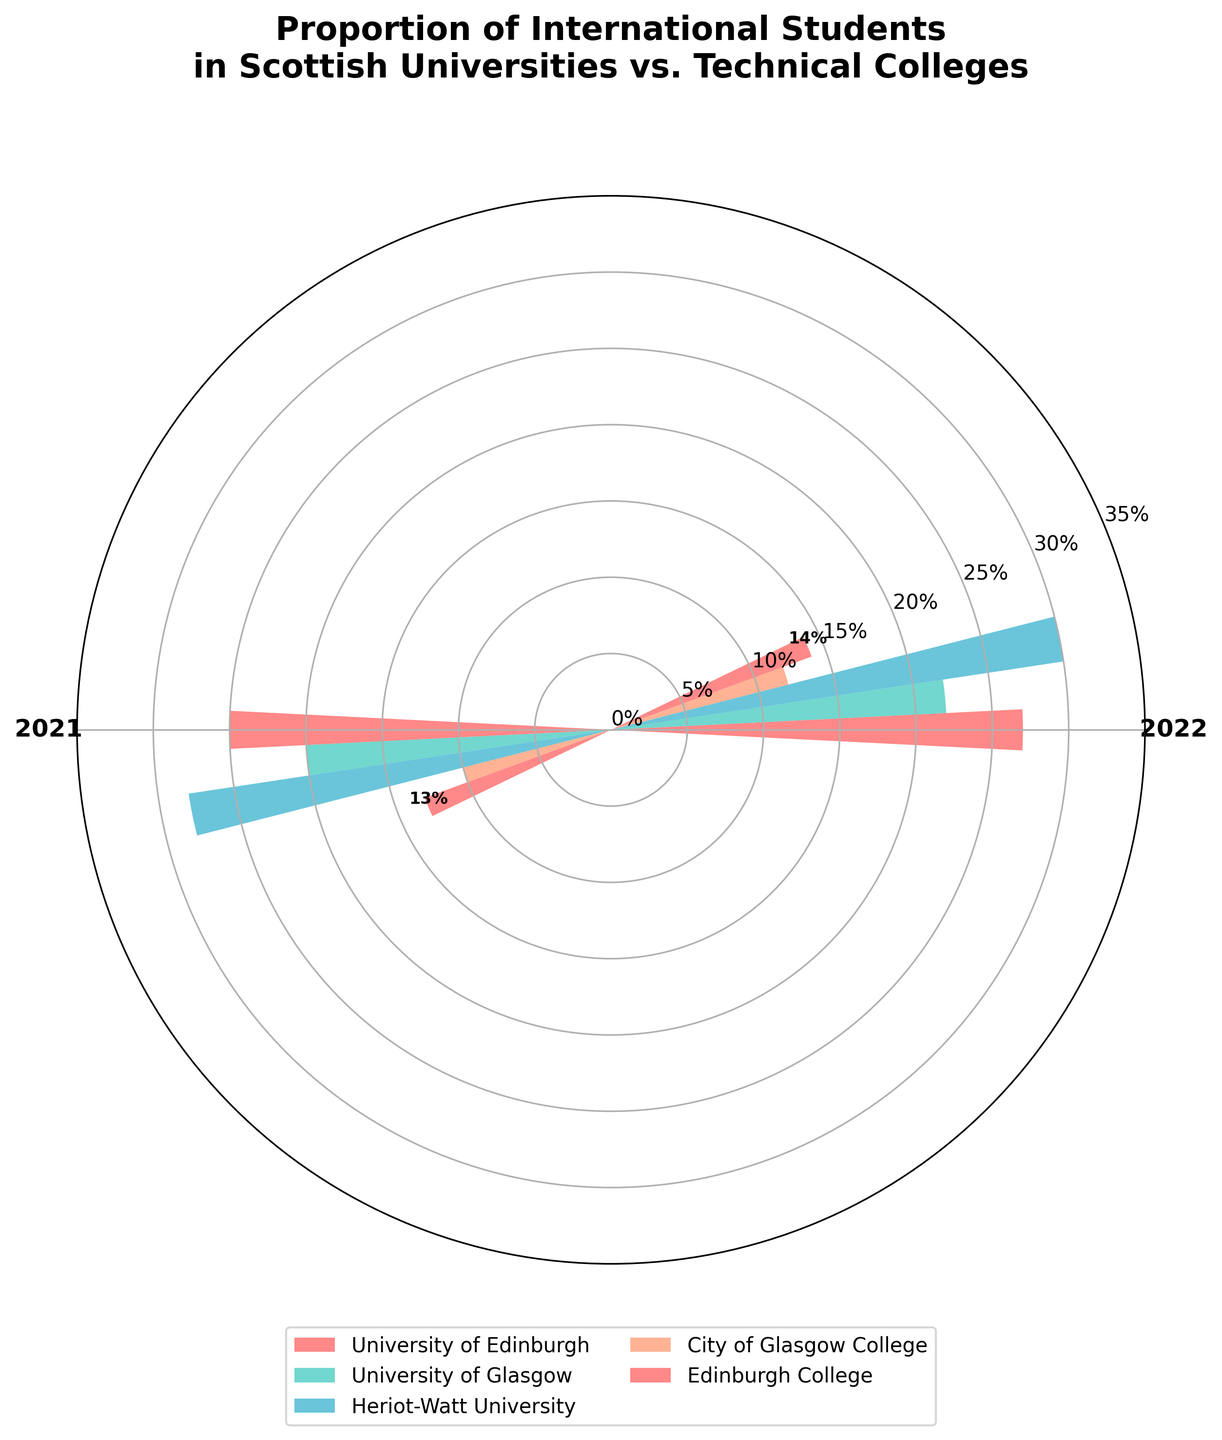What is the percentage of international students at the University of Edinburgh in 2022? The plot shows the percentage of international students for different universities and technical colleges across two years, and we can directly refer to the University of Edinburgh's segment for 2022.
Answer: 27% What is the title of the chart? The title is displayed at the top of the chart and it helps understand the focus of the figure.
Answer: Proportion of International Students in Scottish Universities vs. Technical Colleges Which university had the highest percentage of international students in 2021? By comparing the heights of the bars for each institution in 2021, we find that Heriot-Watt University has the tallest bar.
Answer: Heriot-Watt University What is the difference in the percentage of international students between 2021 and 2022 for the University of Glasgow? Find the height of the University of Glasgow's bars for both years and subtract the 2021 value from the 2022 value (22% - 20%).
Answer: 2% Which institution had a higher percentage of international students in 2022, City of Glasgow College or Edinburgh College? Compare the heights of the bars for 2022 for both institutions: City of Glasgow College has 12% and Edinburgh College has 14%.
Answer: Edinburgh College What is the average percentage of international students in 2021 for all institutions shown? Sum the percentages for all institutions in 2021 (25+20+28+10+13) and divide by the number of institutions (5). (96/5)
Answer: 19.2% Which institution had the least increase in the percentage of international students from 2021 to 2022? Calculate the difference for all institutions and find the smallest: University of Edinburgh (2), University of Glasgow (2), Heriot-Watt University (2), City of Glasgow College (2), and Edinburgh College (1).
Answer: Edinburgh College What is the range of percentages for international students in 2022 across all institutions? Find the difference between the maximum and minimum percentages in 2022. Maximum is Heriot-Watt University at 30% and minimum is City of Glasgow College at 12%. Range is (30-12).
Answer: 18% Which segment has a larger range of percentage values for international students, universities or technical colleges? Calculate the range for universities (max 30% at Heriot-Watt University, min 20% at University of Glasgow) and technical colleges (max 14% at Edinburgh College, min 10% at City of Glasgow College). University range is (30-20)=10% and technical college range is (14-10)=4%.
Answer: Universities Which institutions experienced an increase in the percentage of international students from 2021 to 2022? Examine the height of the bars for each institution and compare 2021 to 2022. Institutions with higher bars in 2022 are University of Edinburgh, University of Glasgow, Heriot-Watt University, City of Glasgow College, and Edinburgh College.
Answer: All Institutions 